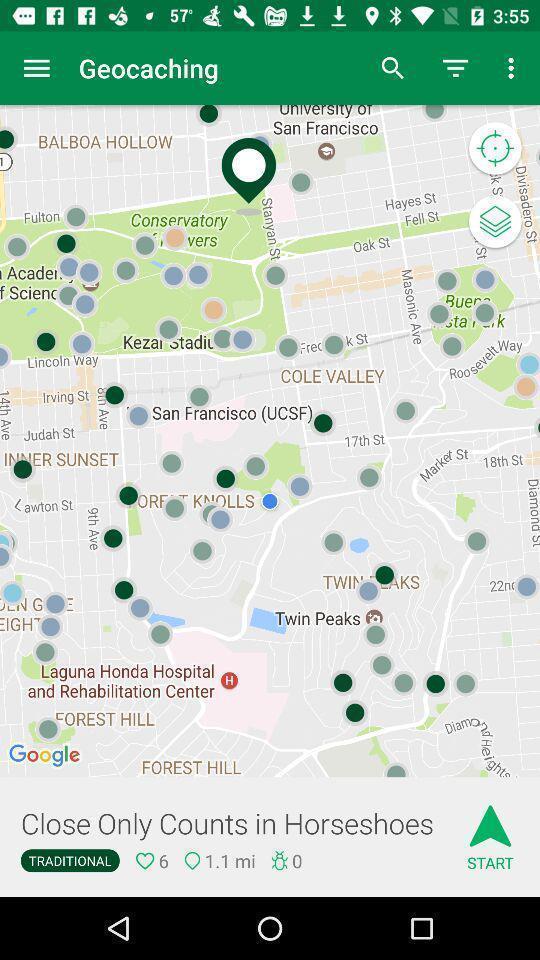Please provide a description for this image. Screen showing map. 